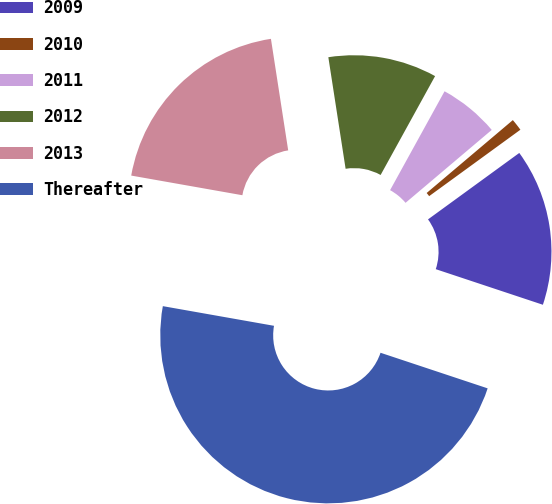Convert chart. <chart><loc_0><loc_0><loc_500><loc_500><pie_chart><fcel>2009<fcel>2010<fcel>2011<fcel>2012<fcel>2013<fcel>Thereafter<nl><fcel>15.12%<fcel>1.16%<fcel>5.81%<fcel>10.46%<fcel>19.77%<fcel>47.68%<nl></chart> 